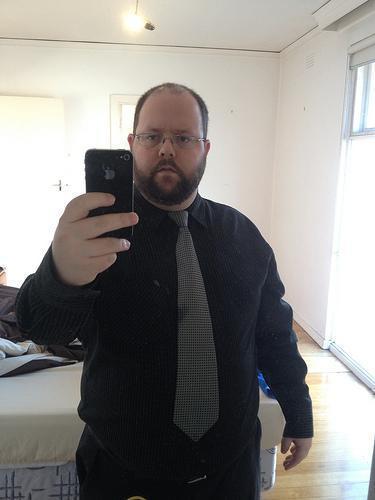How many people?
Give a very brief answer. 1. How many lights?
Give a very brief answer. 1. How many cell phones?
Give a very brief answer. 1. 